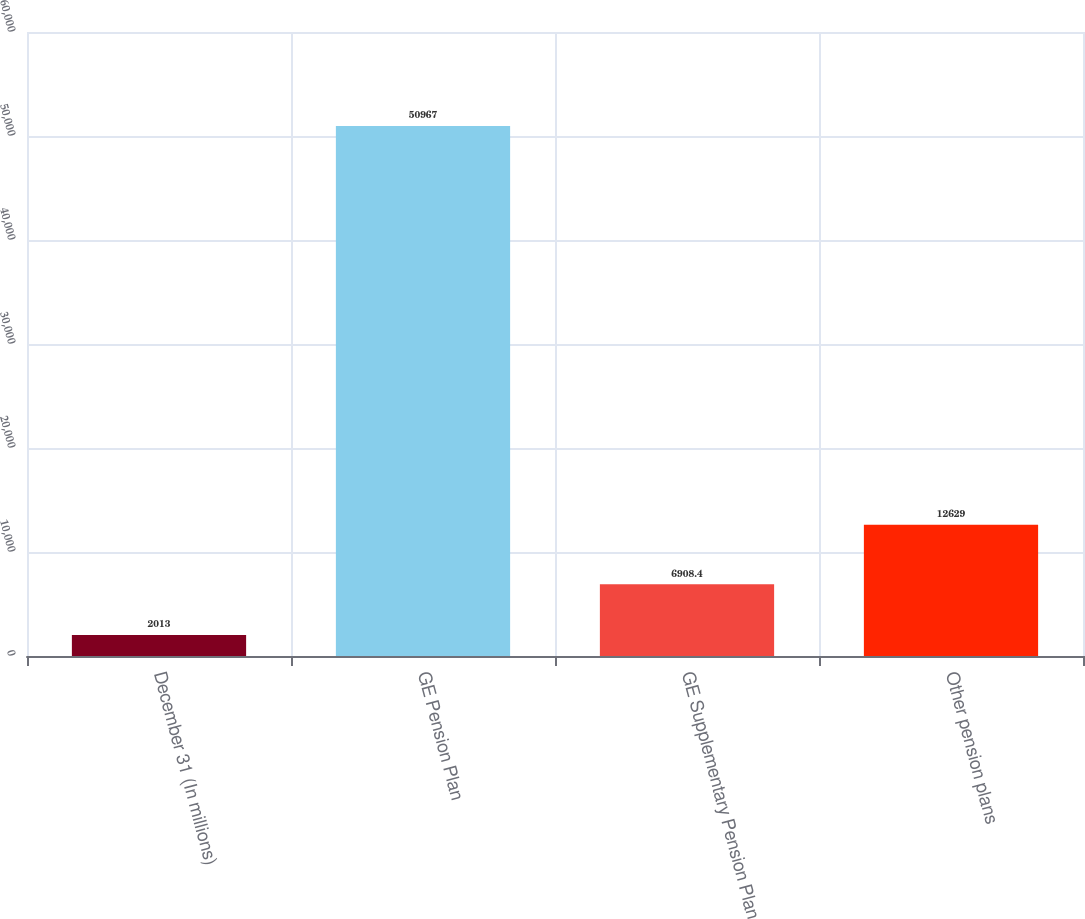Convert chart. <chart><loc_0><loc_0><loc_500><loc_500><bar_chart><fcel>December 31 (In millions)<fcel>GE Pension Plan<fcel>GE Supplementary Pension Plan<fcel>Other pension plans<nl><fcel>2013<fcel>50967<fcel>6908.4<fcel>12629<nl></chart> 